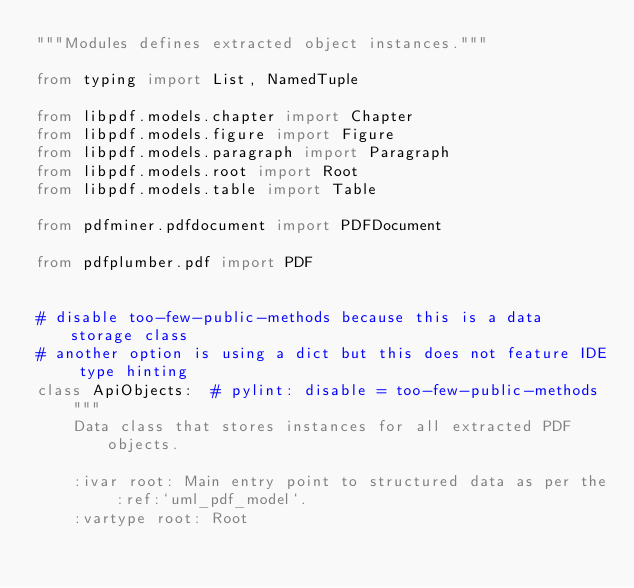<code> <loc_0><loc_0><loc_500><loc_500><_Python_>"""Modules defines extracted object instances."""

from typing import List, NamedTuple

from libpdf.models.chapter import Chapter
from libpdf.models.figure import Figure
from libpdf.models.paragraph import Paragraph
from libpdf.models.root import Root
from libpdf.models.table import Table

from pdfminer.pdfdocument import PDFDocument

from pdfplumber.pdf import PDF


# disable too-few-public-methods because this is a data storage class
# another option is using a dict but this does not feature IDE type hinting
class ApiObjects:  # pylint: disable = too-few-public-methods
    """
    Data class that stores instances for all extracted PDF objects.

    :ivar root: Main entry point to structured data as per the :ref:`uml_pdf_model`.
    :vartype root: Root</code> 